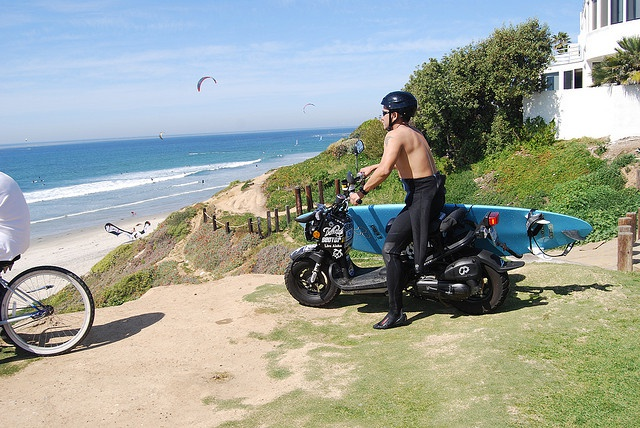Describe the objects in this image and their specific colors. I can see motorcycle in lightblue, black, gray, darkgray, and lightgray tones, people in lightblue, black, tan, and gray tones, bicycle in lightblue, lightgray, gray, black, and darkgray tones, surfboard in lightblue, teal, blue, and black tones, and people in lightblue, darkgray, and lavender tones in this image. 